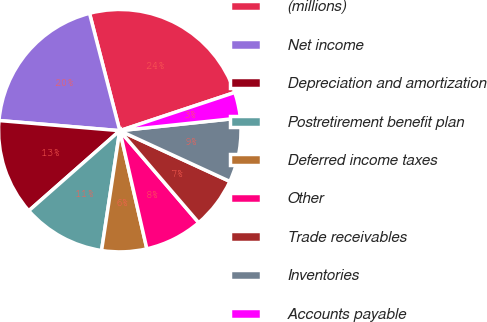Convert chart. <chart><loc_0><loc_0><loc_500><loc_500><pie_chart><fcel>(millions)<fcel>Net income<fcel>Depreciation and amortization<fcel>Postretirement benefit plan<fcel>Deferred income taxes<fcel>Other<fcel>Trade receivables<fcel>Inventories<fcel>Accounts payable<nl><fcel>23.91%<fcel>19.65%<fcel>12.82%<fcel>11.11%<fcel>5.99%<fcel>7.7%<fcel>6.84%<fcel>8.55%<fcel>3.43%<nl></chart> 